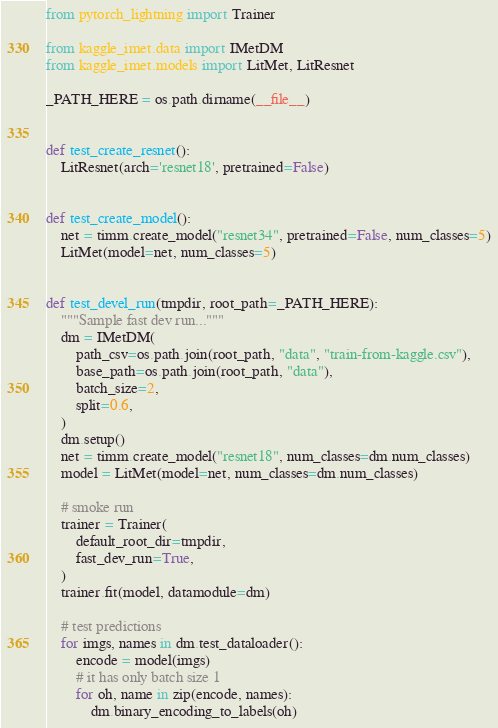Convert code to text. <code><loc_0><loc_0><loc_500><loc_500><_Python_>from pytorch_lightning import Trainer

from kaggle_imet.data import IMetDM
from kaggle_imet.models import LitMet, LitResnet

_PATH_HERE = os.path.dirname(__file__)


def test_create_resnet():
    LitResnet(arch='resnet18', pretrained=False)


def test_create_model():
    net = timm.create_model("resnet34", pretrained=False, num_classes=5)
    LitMet(model=net, num_classes=5)


def test_devel_run(tmpdir, root_path=_PATH_HERE):
    """Sample fast dev run..."""
    dm = IMetDM(
        path_csv=os.path.join(root_path, "data", "train-from-kaggle.csv"),
        base_path=os.path.join(root_path, "data"),
        batch_size=2,
        split=0.6,
    )
    dm.setup()
    net = timm.create_model("resnet18", num_classes=dm.num_classes)
    model = LitMet(model=net, num_classes=dm.num_classes)

    # smoke run
    trainer = Trainer(
        default_root_dir=tmpdir,
        fast_dev_run=True,
    )
    trainer.fit(model, datamodule=dm)

    # test predictions
    for imgs, names in dm.test_dataloader():
        encode = model(imgs)
        # it has only batch size 1
        for oh, name in zip(encode, names):
            dm.binary_encoding_to_labels(oh)
</code> 